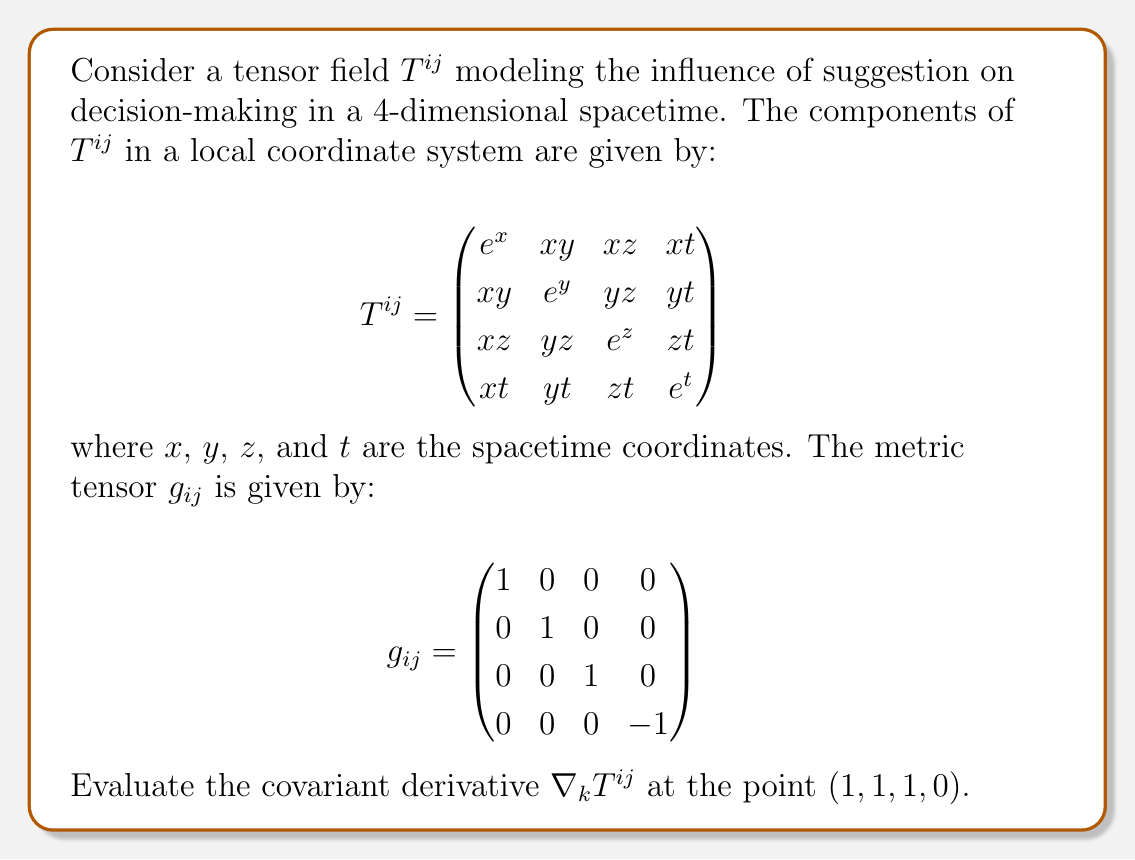Teach me how to tackle this problem. To evaluate the covariant derivative of the tensor field $T^{ij}$, we need to follow these steps:

1) The covariant derivative of a $(2,0)$ tensor is given by:

   $$\nabla_k T^{ij} = \partial_k T^{ij} + \Gamma^i_{km}T^{mj} + \Gamma^j_{kn}T^{in}$$

   where $\Gamma^i_{jk}$ are the Christoffel symbols.

2) First, let's calculate the partial derivatives $\partial_k T^{ij}$ at $(1, 1, 1, 0)$:

   $$\partial_x T^{ij} = \begin{pmatrix}
   e^x & y & z & t \\
   y & 0 & 0 & 0 \\
   z & 0 & 0 & 0 \\
   t & 0 & 0 & 0
   \end{pmatrix} = \begin{pmatrix}
   e & 1 & 1 & 0 \\
   1 & 0 & 0 & 0 \\
   1 & 0 & 0 & 0 \\
   0 & 0 & 0 & 0
   \end{pmatrix}$$

   $$\partial_y T^{ij} = \begin{pmatrix}
   0 & x & 0 & 0 \\
   x & e^y & z & t \\
   0 & z & 0 & 0 \\
   0 & t & 0 & 0
   \end{pmatrix} = \begin{pmatrix}
   0 & 1 & 0 & 0 \\
   1 & e & 1 & 0 \\
   0 & 1 & 0 & 0 \\
   0 & 0 & 0 & 0
   \end{pmatrix}$$

   $$\partial_z T^{ij} = \begin{pmatrix}
   0 & 0 & x & 0 \\
   0 & 0 & y & 0 \\
   x & y & e^z & t \\
   0 & 0 & t & 0
   \end{pmatrix} = \begin{pmatrix}
   0 & 0 & 1 & 0 \\
   0 & 0 & 1 & 0 \\
   1 & 1 & e & 0 \\
   0 & 0 & 0 & 0
   \end{pmatrix}$$

   $$\partial_t T^{ij} = \begin{pmatrix}
   0 & 0 & 0 & x \\
   0 & 0 & 0 & y \\
   0 & 0 & 0 & z \\
   x & y & z & e^t
   \end{pmatrix} = \begin{pmatrix}
   0 & 0 & 0 & 1 \\
   0 & 0 & 0 & 1 \\
   0 & 0 & 0 & 1 \\
   1 & 1 & 1 & 1
   \end{pmatrix}$$

3) Now, we need to calculate the Christoffel symbols. For a metric with components $g_{ij}$, the Christoffel symbols are given by:

   $$\Gamma^i_{jk} = \frac{1}{2}g^{im}(\partial_j g_{mk} + \partial_k g_{mj} - \partial_m g_{jk})$$

   Since the metric is constant, all partial derivatives of $g_{ij}$ are zero. Therefore, all Christoffel symbols are zero.

4) As all Christoffel symbols are zero, the covariant derivative reduces to the partial derivative:

   $$\nabla_k T^{ij} = \partial_k T^{ij}$$

5) Therefore, the covariant derivative $\nabla_k T^{ij}$ at $(1, 1, 1, 0)$ is given by the partial derivatives we calculated in step 2.
Answer: $\nabla_k T^{ij} = \partial_k T^{ij}$ at $(1, 1, 1, 0)$, where $\partial_k T^{ij}$ are the matrices calculated in step 2 of the explanation. 